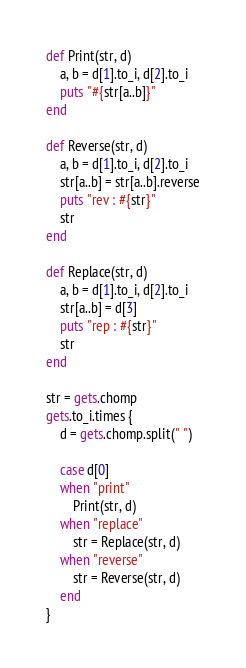<code> <loc_0><loc_0><loc_500><loc_500><_Ruby_>def Print(str, d)
    a, b = d[1].to_i, d[2].to_i
    puts "#{str[a..b]}"
end

def Reverse(str, d)
    a, b = d[1].to_i, d[2].to_i
    str[a..b] = str[a..b].reverse
    puts "rev : #{str}"
    str
end

def Replace(str, d)
    a, b = d[1].to_i, d[2].to_i
    str[a..b] = d[3]
    puts "rep : #{str}"
    str
end

str = gets.chomp
gets.to_i.times {
    d = gets.chomp.split(" ")
    
    case d[0]
    when "print"
        Print(str, d)
    when "replace"
        str = Replace(str, d)
    when "reverse"
        str = Reverse(str, d)
    end
}</code> 